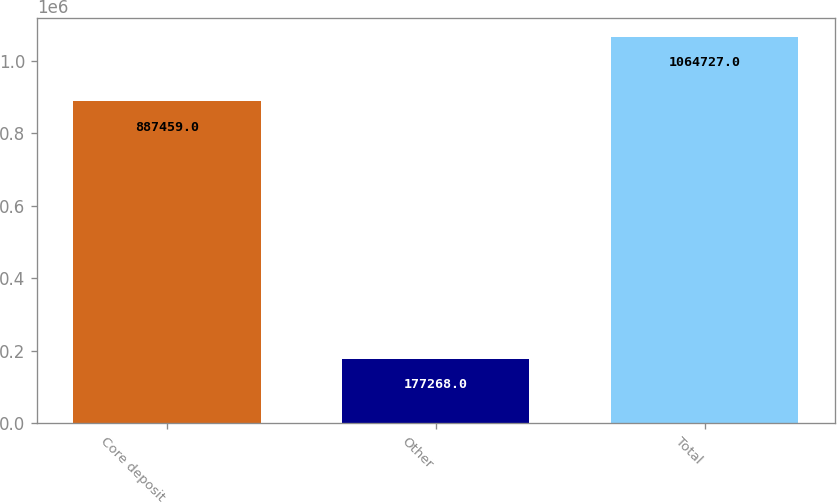<chart> <loc_0><loc_0><loc_500><loc_500><bar_chart><fcel>Core deposit<fcel>Other<fcel>Total<nl><fcel>887459<fcel>177268<fcel>1.06473e+06<nl></chart> 